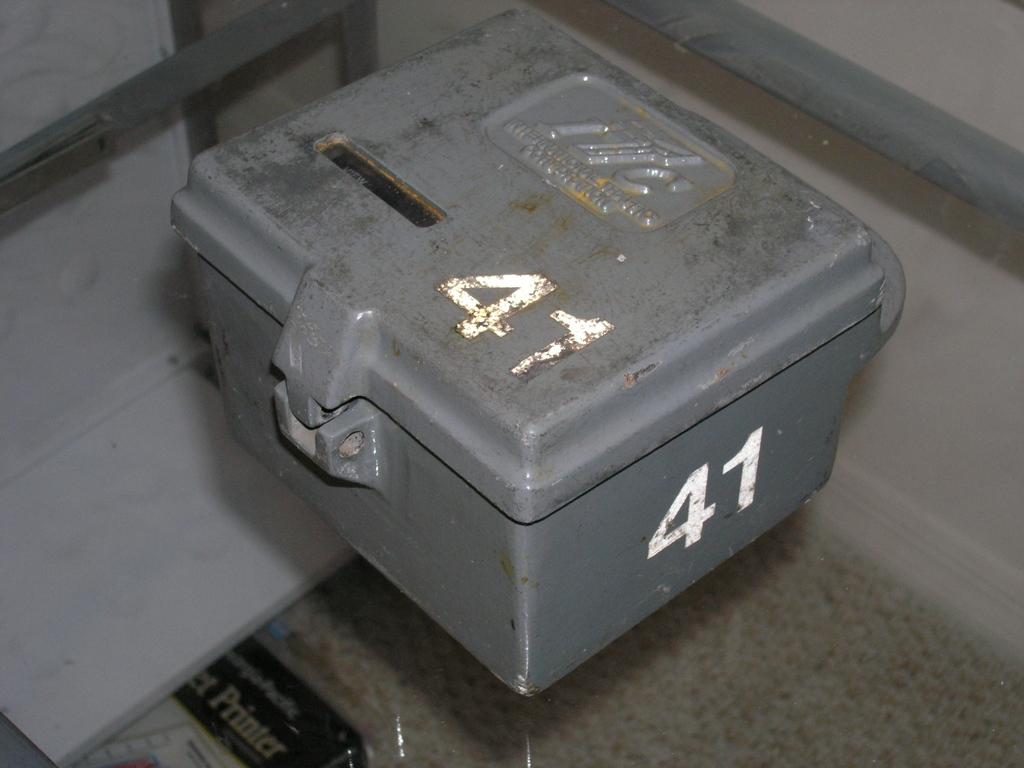What is the number in white?
Offer a terse response. 41. 